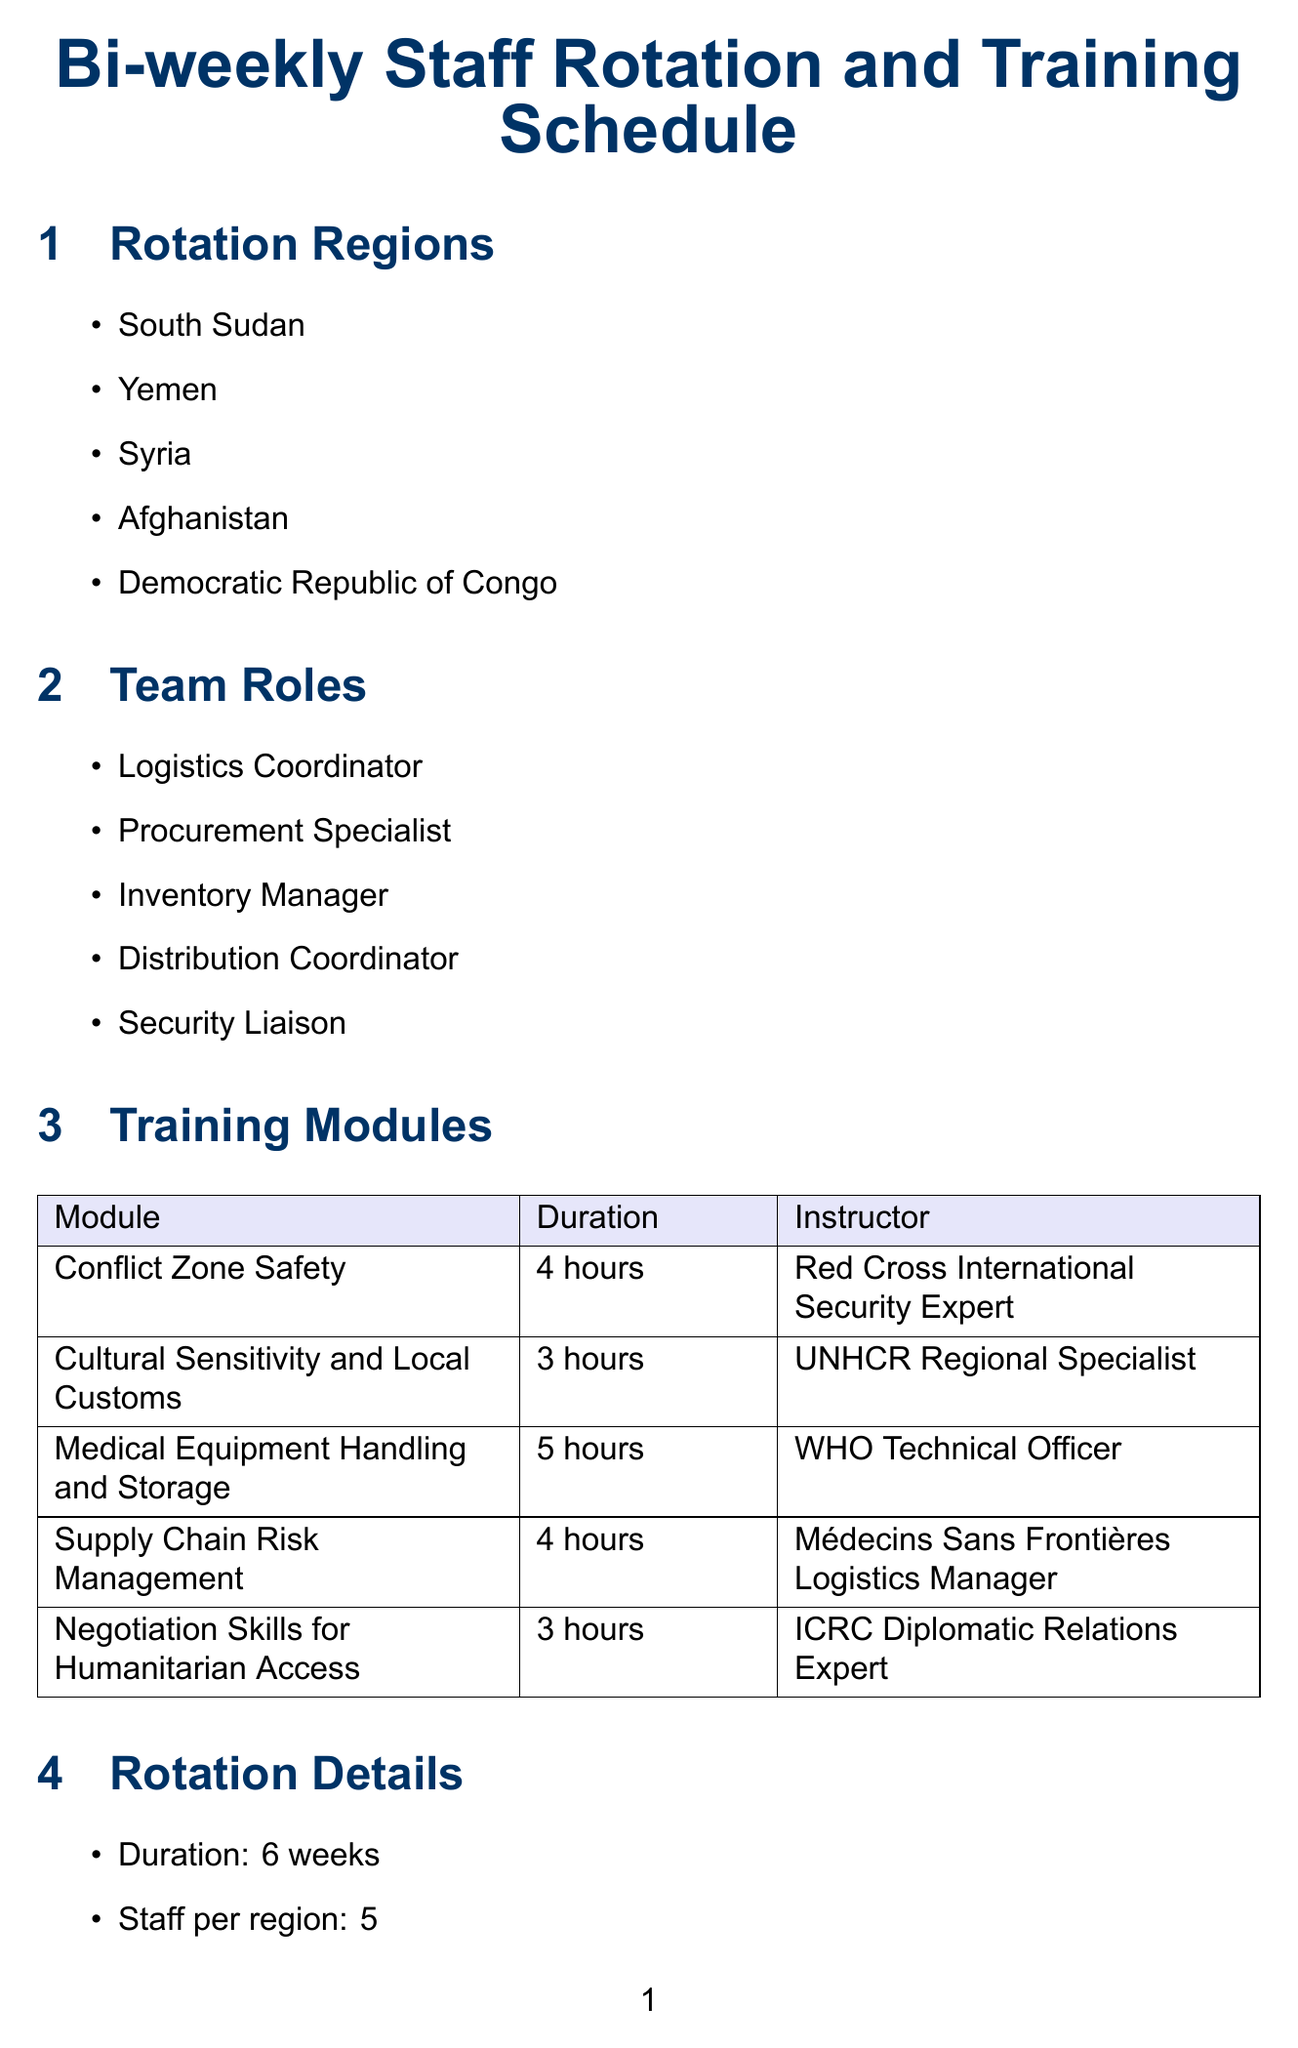what are the rotation regions? The rotation regions are listed in the document as the areas where staff will be deployed.
Answer: South Sudan, Yemen, Syria, Afghanistan, Democratic Republic of Congo how long is the rotation duration? The rotation duration is specified in the document as the period for which staff will be in a region before being rotated.
Answer: 6 weeks who is the instructor for Medical Equipment Handling and Storage? The instructor's name for the specified training module can be found in the training modules section.
Answer: WHO Technical Officer how many staff are assigned per region? The number of staff assigned to each region is explicitly stated in the rotation details section.
Answer: 5 what is the duration of the Conflict Zone Safety training module? The duration for the specified training module is mentioned alongside the module's details.
Answer: 4 hours which organization is responsible for cultural sensitivity training? The organization responsible for the training is indicated in the training modules section.
Answer: UNHCR what are the key partners listed in the document? Key partners are organizations mentioned that collaborate in the supply chain operations.
Answer: World Health Organization, United Nations High Commissioner for Refugees, International Committee of the Red Cross, Médecins Sans Frontières, UNICEF what are potential logistical challenges faced? The challenges faced during operation can be found in the relevant section of the document.
Answer: Limited road access, Customs clearance delays, Security checkpoints, Power outages affecting cold chain, Communication infrastructure breakdowns what type of equipment is included in the supply list? The types of equipment to be delivered to conflict zones are enumerated in the equipment types section.
Answer: Portable X-ray Machines, Ventilators, Surgical Kits, Trauma Kits, Refrigerated Vaccine Storage Units 